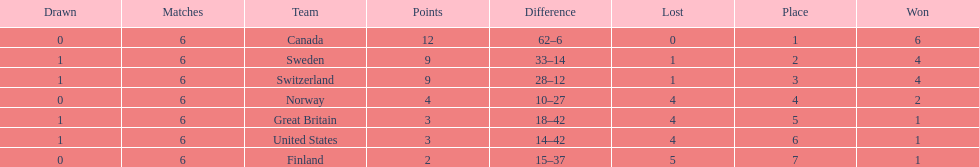Which country finished below the united states? Finland. 